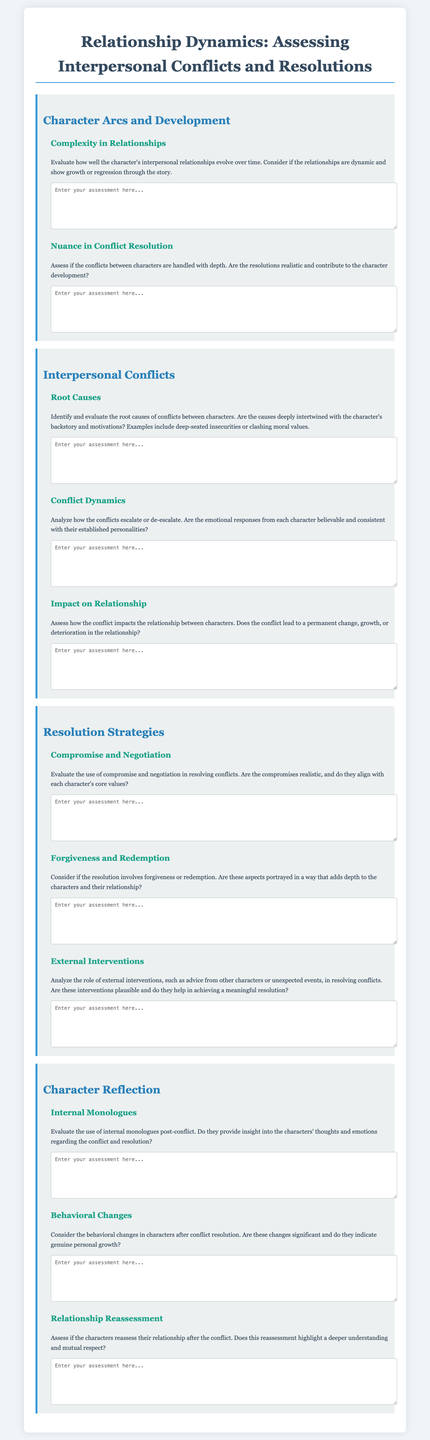What is the title of the form? The title of the form is prominently displayed at the top of the document.
Answer: Relationship Dynamics: Assessing Interpersonal Conflicts and Resolutions How many sections are there in the document? The document is divided into several structured sections detailing aspects of relationships.
Answer: Four What are the two main themes assessed in the first section? The first section focuses on specific themes regarding relationship dynamics.
Answer: Complexity in Relationships, Nuance in Conflict Resolution What is the focus of the "Root Causes" subsection? The subsection addresses the underlying issues that lead to conflicts between characters.
Answer: Identify and evaluate the root causes of conflicts Which resolution strategy is related to character redemption? This strategy specifically addresses the concepts of forgiveness and personal growth after conflicts.
Answer: Forgiveness and Redemption What is evaluated in the "Behavioral Changes" subsection? This subsection assesses the transformations characters undergo post-conflict.
Answer: Consider the behavioral changes in characters after conflict resolution What type of interventions are analyzed in the "External Interventions" subsection? This subsection focuses on the influence of outside factors in resolving conflicts.
Answer: Role of external interventions What literary tool is assessed in the "Internal Monologues" subsection? This tool provides insight into character thoughts and emotions concerning conflicts.
Answer: Evaluate the use of internal monologues post-conflict 